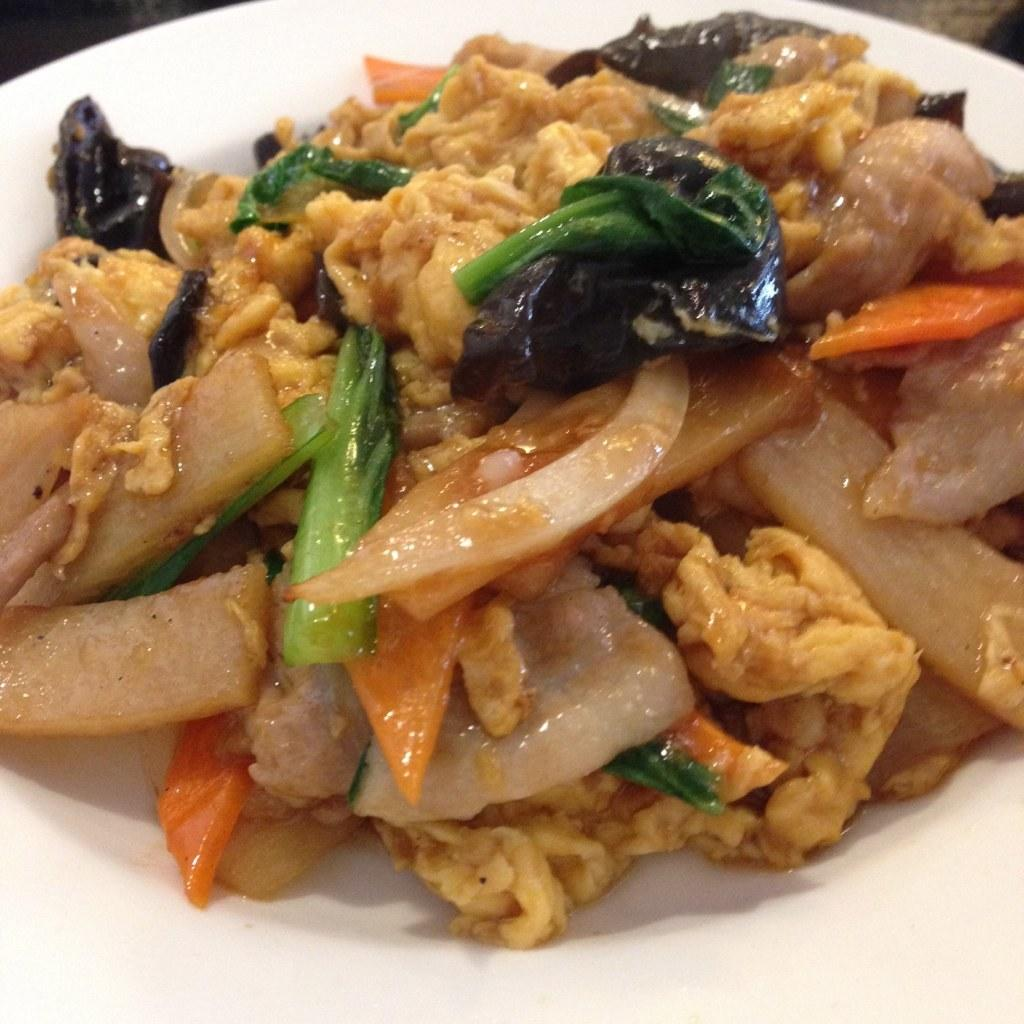What is the main subject of the image? There is a food item on a plate in the image. Can you tell me how many rivers are visible in the image? There are no rivers visible in the image; it features a food item on a plate. What type of brush is being used to create the food item in the image? There is no brush or creation process depicted in the image; it simply shows a food item on a plate. 